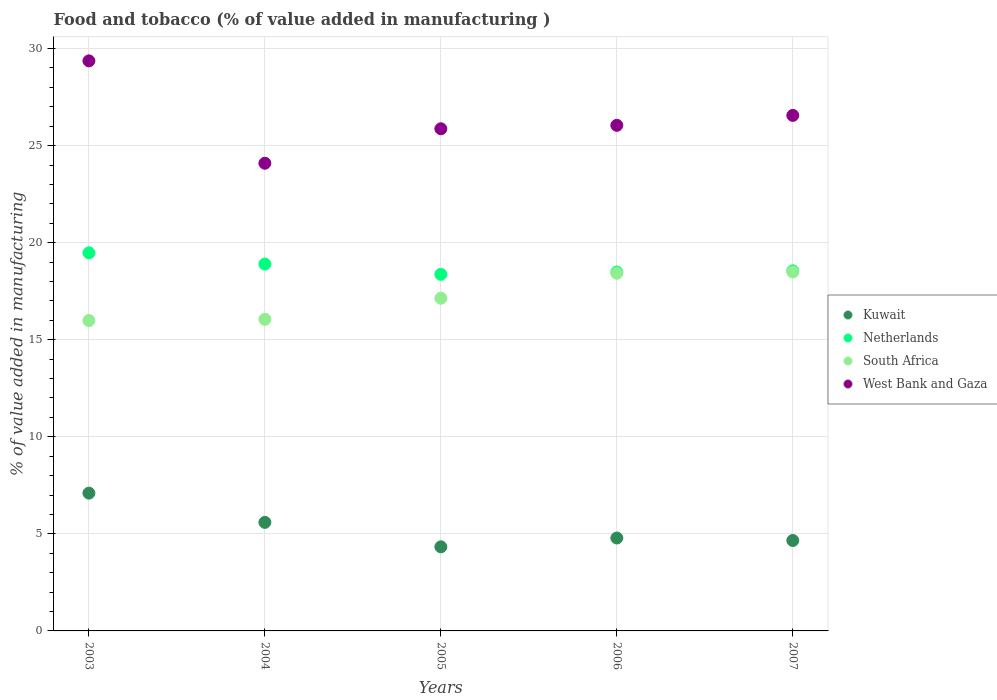How many different coloured dotlines are there?
Offer a very short reply. 4. What is the value added in manufacturing food and tobacco in Netherlands in 2006?
Ensure brevity in your answer.  18.49. Across all years, what is the maximum value added in manufacturing food and tobacco in Kuwait?
Offer a terse response. 7.1. Across all years, what is the minimum value added in manufacturing food and tobacco in Netherlands?
Provide a succinct answer. 18.37. In which year was the value added in manufacturing food and tobacco in West Bank and Gaza minimum?
Your answer should be very brief. 2004. What is the total value added in manufacturing food and tobacco in Kuwait in the graph?
Provide a succinct answer. 26.47. What is the difference between the value added in manufacturing food and tobacco in Netherlands in 2004 and that in 2005?
Provide a short and direct response. 0.53. What is the difference between the value added in manufacturing food and tobacco in West Bank and Gaza in 2004 and the value added in manufacturing food and tobacco in South Africa in 2007?
Offer a terse response. 5.6. What is the average value added in manufacturing food and tobacco in South Africa per year?
Ensure brevity in your answer.  17.22. In the year 2004, what is the difference between the value added in manufacturing food and tobacco in Netherlands and value added in manufacturing food and tobacco in West Bank and Gaza?
Offer a very short reply. -5.19. What is the ratio of the value added in manufacturing food and tobacco in South Africa in 2003 to that in 2005?
Provide a short and direct response. 0.93. Is the value added in manufacturing food and tobacco in South Africa in 2005 less than that in 2006?
Your answer should be compact. Yes. What is the difference between the highest and the second highest value added in manufacturing food and tobacco in Netherlands?
Ensure brevity in your answer.  0.58. What is the difference between the highest and the lowest value added in manufacturing food and tobacco in Netherlands?
Give a very brief answer. 1.11. In how many years, is the value added in manufacturing food and tobacco in Kuwait greater than the average value added in manufacturing food and tobacco in Kuwait taken over all years?
Provide a succinct answer. 2. Is the sum of the value added in manufacturing food and tobacco in Netherlands in 2005 and 2007 greater than the maximum value added in manufacturing food and tobacco in Kuwait across all years?
Your answer should be very brief. Yes. Is it the case that in every year, the sum of the value added in manufacturing food and tobacco in West Bank and Gaza and value added in manufacturing food and tobacco in Netherlands  is greater than the sum of value added in manufacturing food and tobacco in South Africa and value added in manufacturing food and tobacco in Kuwait?
Ensure brevity in your answer.  No. Is it the case that in every year, the sum of the value added in manufacturing food and tobacco in South Africa and value added in manufacturing food and tobacco in Netherlands  is greater than the value added in manufacturing food and tobacco in West Bank and Gaza?
Your response must be concise. Yes. Does the value added in manufacturing food and tobacco in West Bank and Gaza monotonically increase over the years?
Ensure brevity in your answer.  No. How many years are there in the graph?
Offer a very short reply. 5. What is the difference between two consecutive major ticks on the Y-axis?
Keep it short and to the point. 5. Are the values on the major ticks of Y-axis written in scientific E-notation?
Offer a very short reply. No. Does the graph contain any zero values?
Offer a terse response. No. Does the graph contain grids?
Offer a terse response. Yes. How are the legend labels stacked?
Offer a terse response. Vertical. What is the title of the graph?
Keep it short and to the point. Food and tobacco (% of value added in manufacturing ). What is the label or title of the Y-axis?
Your answer should be compact. % of value added in manufacturing. What is the % of value added in manufacturing in Kuwait in 2003?
Provide a succinct answer. 7.1. What is the % of value added in manufacturing in Netherlands in 2003?
Provide a succinct answer. 19.48. What is the % of value added in manufacturing of South Africa in 2003?
Your answer should be very brief. 15.99. What is the % of value added in manufacturing in West Bank and Gaza in 2003?
Keep it short and to the point. 29.36. What is the % of value added in manufacturing of Kuwait in 2004?
Provide a short and direct response. 5.59. What is the % of value added in manufacturing of Netherlands in 2004?
Give a very brief answer. 18.9. What is the % of value added in manufacturing in South Africa in 2004?
Your answer should be very brief. 16.05. What is the % of value added in manufacturing of West Bank and Gaza in 2004?
Ensure brevity in your answer.  24.09. What is the % of value added in manufacturing in Kuwait in 2005?
Offer a terse response. 4.33. What is the % of value added in manufacturing in Netherlands in 2005?
Your answer should be very brief. 18.37. What is the % of value added in manufacturing of South Africa in 2005?
Your response must be concise. 17.14. What is the % of value added in manufacturing in West Bank and Gaza in 2005?
Provide a succinct answer. 25.87. What is the % of value added in manufacturing in Kuwait in 2006?
Keep it short and to the point. 4.79. What is the % of value added in manufacturing in Netherlands in 2006?
Offer a very short reply. 18.49. What is the % of value added in manufacturing in South Africa in 2006?
Keep it short and to the point. 18.42. What is the % of value added in manufacturing in West Bank and Gaza in 2006?
Give a very brief answer. 26.04. What is the % of value added in manufacturing of Kuwait in 2007?
Provide a succinct answer. 4.66. What is the % of value added in manufacturing in Netherlands in 2007?
Offer a terse response. 18.55. What is the % of value added in manufacturing of South Africa in 2007?
Your answer should be compact. 18.49. What is the % of value added in manufacturing of West Bank and Gaza in 2007?
Offer a very short reply. 26.56. Across all years, what is the maximum % of value added in manufacturing in Kuwait?
Offer a terse response. 7.1. Across all years, what is the maximum % of value added in manufacturing of Netherlands?
Provide a short and direct response. 19.48. Across all years, what is the maximum % of value added in manufacturing in South Africa?
Provide a succinct answer. 18.49. Across all years, what is the maximum % of value added in manufacturing of West Bank and Gaza?
Offer a very short reply. 29.36. Across all years, what is the minimum % of value added in manufacturing in Kuwait?
Make the answer very short. 4.33. Across all years, what is the minimum % of value added in manufacturing of Netherlands?
Your response must be concise. 18.37. Across all years, what is the minimum % of value added in manufacturing in South Africa?
Ensure brevity in your answer.  15.99. Across all years, what is the minimum % of value added in manufacturing in West Bank and Gaza?
Your response must be concise. 24.09. What is the total % of value added in manufacturing of Kuwait in the graph?
Offer a terse response. 26.47. What is the total % of value added in manufacturing in Netherlands in the graph?
Ensure brevity in your answer.  93.78. What is the total % of value added in manufacturing in South Africa in the graph?
Your answer should be compact. 86.09. What is the total % of value added in manufacturing in West Bank and Gaza in the graph?
Provide a short and direct response. 131.92. What is the difference between the % of value added in manufacturing in Kuwait in 2003 and that in 2004?
Make the answer very short. 1.51. What is the difference between the % of value added in manufacturing of Netherlands in 2003 and that in 2004?
Provide a succinct answer. 0.58. What is the difference between the % of value added in manufacturing in South Africa in 2003 and that in 2004?
Provide a short and direct response. -0.06. What is the difference between the % of value added in manufacturing in West Bank and Gaza in 2003 and that in 2004?
Provide a succinct answer. 5.27. What is the difference between the % of value added in manufacturing in Kuwait in 2003 and that in 2005?
Your response must be concise. 2.77. What is the difference between the % of value added in manufacturing of Netherlands in 2003 and that in 2005?
Make the answer very short. 1.11. What is the difference between the % of value added in manufacturing in South Africa in 2003 and that in 2005?
Give a very brief answer. -1.15. What is the difference between the % of value added in manufacturing of West Bank and Gaza in 2003 and that in 2005?
Offer a very short reply. 3.5. What is the difference between the % of value added in manufacturing in Kuwait in 2003 and that in 2006?
Your answer should be very brief. 2.31. What is the difference between the % of value added in manufacturing in South Africa in 2003 and that in 2006?
Your answer should be very brief. -2.43. What is the difference between the % of value added in manufacturing of West Bank and Gaza in 2003 and that in 2006?
Provide a succinct answer. 3.32. What is the difference between the % of value added in manufacturing of Kuwait in 2003 and that in 2007?
Keep it short and to the point. 2.44. What is the difference between the % of value added in manufacturing in Netherlands in 2003 and that in 2007?
Provide a succinct answer. 0.93. What is the difference between the % of value added in manufacturing in South Africa in 2003 and that in 2007?
Offer a very short reply. -2.5. What is the difference between the % of value added in manufacturing of West Bank and Gaza in 2003 and that in 2007?
Provide a short and direct response. 2.81. What is the difference between the % of value added in manufacturing in Kuwait in 2004 and that in 2005?
Offer a terse response. 1.26. What is the difference between the % of value added in manufacturing of Netherlands in 2004 and that in 2005?
Offer a terse response. 0.53. What is the difference between the % of value added in manufacturing of South Africa in 2004 and that in 2005?
Ensure brevity in your answer.  -1.09. What is the difference between the % of value added in manufacturing of West Bank and Gaza in 2004 and that in 2005?
Your response must be concise. -1.78. What is the difference between the % of value added in manufacturing of Kuwait in 2004 and that in 2006?
Your answer should be very brief. 0.81. What is the difference between the % of value added in manufacturing of Netherlands in 2004 and that in 2006?
Your answer should be compact. 0.41. What is the difference between the % of value added in manufacturing in South Africa in 2004 and that in 2006?
Your answer should be compact. -2.37. What is the difference between the % of value added in manufacturing of West Bank and Gaza in 2004 and that in 2006?
Provide a succinct answer. -1.95. What is the difference between the % of value added in manufacturing of Kuwait in 2004 and that in 2007?
Offer a terse response. 0.93. What is the difference between the % of value added in manufacturing in Netherlands in 2004 and that in 2007?
Offer a terse response. 0.35. What is the difference between the % of value added in manufacturing of South Africa in 2004 and that in 2007?
Your response must be concise. -2.44. What is the difference between the % of value added in manufacturing of West Bank and Gaza in 2004 and that in 2007?
Ensure brevity in your answer.  -2.46. What is the difference between the % of value added in manufacturing in Kuwait in 2005 and that in 2006?
Provide a short and direct response. -0.45. What is the difference between the % of value added in manufacturing in Netherlands in 2005 and that in 2006?
Keep it short and to the point. -0.12. What is the difference between the % of value added in manufacturing in South Africa in 2005 and that in 2006?
Ensure brevity in your answer.  -1.29. What is the difference between the % of value added in manufacturing of West Bank and Gaza in 2005 and that in 2006?
Make the answer very short. -0.18. What is the difference between the % of value added in manufacturing in Kuwait in 2005 and that in 2007?
Offer a terse response. -0.33. What is the difference between the % of value added in manufacturing of Netherlands in 2005 and that in 2007?
Offer a very short reply. -0.18. What is the difference between the % of value added in manufacturing in South Africa in 2005 and that in 2007?
Your response must be concise. -1.35. What is the difference between the % of value added in manufacturing of West Bank and Gaza in 2005 and that in 2007?
Ensure brevity in your answer.  -0.69. What is the difference between the % of value added in manufacturing of Kuwait in 2006 and that in 2007?
Keep it short and to the point. 0.13. What is the difference between the % of value added in manufacturing of Netherlands in 2006 and that in 2007?
Offer a terse response. -0.06. What is the difference between the % of value added in manufacturing in South Africa in 2006 and that in 2007?
Offer a very short reply. -0.07. What is the difference between the % of value added in manufacturing of West Bank and Gaza in 2006 and that in 2007?
Offer a terse response. -0.51. What is the difference between the % of value added in manufacturing of Kuwait in 2003 and the % of value added in manufacturing of Netherlands in 2004?
Make the answer very short. -11.8. What is the difference between the % of value added in manufacturing of Kuwait in 2003 and the % of value added in manufacturing of South Africa in 2004?
Give a very brief answer. -8.95. What is the difference between the % of value added in manufacturing of Kuwait in 2003 and the % of value added in manufacturing of West Bank and Gaza in 2004?
Your response must be concise. -16.99. What is the difference between the % of value added in manufacturing in Netherlands in 2003 and the % of value added in manufacturing in South Africa in 2004?
Offer a terse response. 3.43. What is the difference between the % of value added in manufacturing in Netherlands in 2003 and the % of value added in manufacturing in West Bank and Gaza in 2004?
Your answer should be compact. -4.62. What is the difference between the % of value added in manufacturing of South Africa in 2003 and the % of value added in manufacturing of West Bank and Gaza in 2004?
Provide a succinct answer. -8.1. What is the difference between the % of value added in manufacturing in Kuwait in 2003 and the % of value added in manufacturing in Netherlands in 2005?
Make the answer very short. -11.27. What is the difference between the % of value added in manufacturing of Kuwait in 2003 and the % of value added in manufacturing of South Africa in 2005?
Your response must be concise. -10.04. What is the difference between the % of value added in manufacturing in Kuwait in 2003 and the % of value added in manufacturing in West Bank and Gaza in 2005?
Your answer should be compact. -18.77. What is the difference between the % of value added in manufacturing in Netherlands in 2003 and the % of value added in manufacturing in South Africa in 2005?
Provide a succinct answer. 2.34. What is the difference between the % of value added in manufacturing of Netherlands in 2003 and the % of value added in manufacturing of West Bank and Gaza in 2005?
Ensure brevity in your answer.  -6.39. What is the difference between the % of value added in manufacturing in South Africa in 2003 and the % of value added in manufacturing in West Bank and Gaza in 2005?
Your answer should be compact. -9.88. What is the difference between the % of value added in manufacturing of Kuwait in 2003 and the % of value added in manufacturing of Netherlands in 2006?
Offer a terse response. -11.39. What is the difference between the % of value added in manufacturing in Kuwait in 2003 and the % of value added in manufacturing in South Africa in 2006?
Provide a succinct answer. -11.33. What is the difference between the % of value added in manufacturing in Kuwait in 2003 and the % of value added in manufacturing in West Bank and Gaza in 2006?
Keep it short and to the point. -18.95. What is the difference between the % of value added in manufacturing of Netherlands in 2003 and the % of value added in manufacturing of South Africa in 2006?
Give a very brief answer. 1.05. What is the difference between the % of value added in manufacturing of Netherlands in 2003 and the % of value added in manufacturing of West Bank and Gaza in 2006?
Your response must be concise. -6.57. What is the difference between the % of value added in manufacturing of South Africa in 2003 and the % of value added in manufacturing of West Bank and Gaza in 2006?
Your answer should be compact. -10.05. What is the difference between the % of value added in manufacturing of Kuwait in 2003 and the % of value added in manufacturing of Netherlands in 2007?
Keep it short and to the point. -11.45. What is the difference between the % of value added in manufacturing of Kuwait in 2003 and the % of value added in manufacturing of South Africa in 2007?
Make the answer very short. -11.39. What is the difference between the % of value added in manufacturing in Kuwait in 2003 and the % of value added in manufacturing in West Bank and Gaza in 2007?
Give a very brief answer. -19.46. What is the difference between the % of value added in manufacturing in Netherlands in 2003 and the % of value added in manufacturing in South Africa in 2007?
Provide a short and direct response. 0.98. What is the difference between the % of value added in manufacturing in Netherlands in 2003 and the % of value added in manufacturing in West Bank and Gaza in 2007?
Offer a very short reply. -7.08. What is the difference between the % of value added in manufacturing of South Africa in 2003 and the % of value added in manufacturing of West Bank and Gaza in 2007?
Your answer should be very brief. -10.57. What is the difference between the % of value added in manufacturing of Kuwait in 2004 and the % of value added in manufacturing of Netherlands in 2005?
Your response must be concise. -12.78. What is the difference between the % of value added in manufacturing of Kuwait in 2004 and the % of value added in manufacturing of South Africa in 2005?
Make the answer very short. -11.55. What is the difference between the % of value added in manufacturing in Kuwait in 2004 and the % of value added in manufacturing in West Bank and Gaza in 2005?
Provide a short and direct response. -20.28. What is the difference between the % of value added in manufacturing of Netherlands in 2004 and the % of value added in manufacturing of South Africa in 2005?
Offer a terse response. 1.76. What is the difference between the % of value added in manufacturing in Netherlands in 2004 and the % of value added in manufacturing in West Bank and Gaza in 2005?
Ensure brevity in your answer.  -6.97. What is the difference between the % of value added in manufacturing of South Africa in 2004 and the % of value added in manufacturing of West Bank and Gaza in 2005?
Provide a succinct answer. -9.82. What is the difference between the % of value added in manufacturing in Kuwait in 2004 and the % of value added in manufacturing in Netherlands in 2006?
Ensure brevity in your answer.  -12.9. What is the difference between the % of value added in manufacturing of Kuwait in 2004 and the % of value added in manufacturing of South Africa in 2006?
Provide a succinct answer. -12.83. What is the difference between the % of value added in manufacturing in Kuwait in 2004 and the % of value added in manufacturing in West Bank and Gaza in 2006?
Provide a succinct answer. -20.45. What is the difference between the % of value added in manufacturing in Netherlands in 2004 and the % of value added in manufacturing in South Africa in 2006?
Ensure brevity in your answer.  0.47. What is the difference between the % of value added in manufacturing in Netherlands in 2004 and the % of value added in manufacturing in West Bank and Gaza in 2006?
Your answer should be compact. -7.15. What is the difference between the % of value added in manufacturing in South Africa in 2004 and the % of value added in manufacturing in West Bank and Gaza in 2006?
Provide a succinct answer. -9.99. What is the difference between the % of value added in manufacturing of Kuwait in 2004 and the % of value added in manufacturing of Netherlands in 2007?
Your answer should be compact. -12.96. What is the difference between the % of value added in manufacturing of Kuwait in 2004 and the % of value added in manufacturing of South Africa in 2007?
Provide a succinct answer. -12.9. What is the difference between the % of value added in manufacturing of Kuwait in 2004 and the % of value added in manufacturing of West Bank and Gaza in 2007?
Keep it short and to the point. -20.96. What is the difference between the % of value added in manufacturing of Netherlands in 2004 and the % of value added in manufacturing of South Africa in 2007?
Give a very brief answer. 0.41. What is the difference between the % of value added in manufacturing of Netherlands in 2004 and the % of value added in manufacturing of West Bank and Gaza in 2007?
Offer a very short reply. -7.66. What is the difference between the % of value added in manufacturing of South Africa in 2004 and the % of value added in manufacturing of West Bank and Gaza in 2007?
Provide a succinct answer. -10.5. What is the difference between the % of value added in manufacturing of Kuwait in 2005 and the % of value added in manufacturing of Netherlands in 2006?
Your response must be concise. -14.16. What is the difference between the % of value added in manufacturing in Kuwait in 2005 and the % of value added in manufacturing in South Africa in 2006?
Your answer should be compact. -14.09. What is the difference between the % of value added in manufacturing of Kuwait in 2005 and the % of value added in manufacturing of West Bank and Gaza in 2006?
Your response must be concise. -21.71. What is the difference between the % of value added in manufacturing of Netherlands in 2005 and the % of value added in manufacturing of South Africa in 2006?
Make the answer very short. -0.06. What is the difference between the % of value added in manufacturing of Netherlands in 2005 and the % of value added in manufacturing of West Bank and Gaza in 2006?
Your answer should be compact. -7.68. What is the difference between the % of value added in manufacturing in South Africa in 2005 and the % of value added in manufacturing in West Bank and Gaza in 2006?
Your answer should be very brief. -8.91. What is the difference between the % of value added in manufacturing of Kuwait in 2005 and the % of value added in manufacturing of Netherlands in 2007?
Offer a very short reply. -14.22. What is the difference between the % of value added in manufacturing in Kuwait in 2005 and the % of value added in manufacturing in South Africa in 2007?
Provide a succinct answer. -14.16. What is the difference between the % of value added in manufacturing in Kuwait in 2005 and the % of value added in manufacturing in West Bank and Gaza in 2007?
Make the answer very short. -22.22. What is the difference between the % of value added in manufacturing of Netherlands in 2005 and the % of value added in manufacturing of South Africa in 2007?
Give a very brief answer. -0.12. What is the difference between the % of value added in manufacturing of Netherlands in 2005 and the % of value added in manufacturing of West Bank and Gaza in 2007?
Keep it short and to the point. -8.19. What is the difference between the % of value added in manufacturing of South Africa in 2005 and the % of value added in manufacturing of West Bank and Gaza in 2007?
Your answer should be compact. -9.42. What is the difference between the % of value added in manufacturing in Kuwait in 2006 and the % of value added in manufacturing in Netherlands in 2007?
Your answer should be very brief. -13.76. What is the difference between the % of value added in manufacturing of Kuwait in 2006 and the % of value added in manufacturing of South Africa in 2007?
Keep it short and to the point. -13.71. What is the difference between the % of value added in manufacturing of Kuwait in 2006 and the % of value added in manufacturing of West Bank and Gaza in 2007?
Your answer should be compact. -21.77. What is the difference between the % of value added in manufacturing of Netherlands in 2006 and the % of value added in manufacturing of South Africa in 2007?
Your response must be concise. -0. What is the difference between the % of value added in manufacturing of Netherlands in 2006 and the % of value added in manufacturing of West Bank and Gaza in 2007?
Make the answer very short. -8.07. What is the difference between the % of value added in manufacturing of South Africa in 2006 and the % of value added in manufacturing of West Bank and Gaza in 2007?
Your answer should be very brief. -8.13. What is the average % of value added in manufacturing of Kuwait per year?
Keep it short and to the point. 5.29. What is the average % of value added in manufacturing of Netherlands per year?
Your answer should be compact. 18.76. What is the average % of value added in manufacturing in South Africa per year?
Provide a succinct answer. 17.22. What is the average % of value added in manufacturing in West Bank and Gaza per year?
Make the answer very short. 26.38. In the year 2003, what is the difference between the % of value added in manufacturing in Kuwait and % of value added in manufacturing in Netherlands?
Ensure brevity in your answer.  -12.38. In the year 2003, what is the difference between the % of value added in manufacturing in Kuwait and % of value added in manufacturing in South Africa?
Provide a short and direct response. -8.89. In the year 2003, what is the difference between the % of value added in manufacturing in Kuwait and % of value added in manufacturing in West Bank and Gaza?
Offer a terse response. -22.27. In the year 2003, what is the difference between the % of value added in manufacturing in Netherlands and % of value added in manufacturing in South Africa?
Offer a very short reply. 3.49. In the year 2003, what is the difference between the % of value added in manufacturing in Netherlands and % of value added in manufacturing in West Bank and Gaza?
Ensure brevity in your answer.  -9.89. In the year 2003, what is the difference between the % of value added in manufacturing of South Africa and % of value added in manufacturing of West Bank and Gaza?
Your answer should be compact. -13.37. In the year 2004, what is the difference between the % of value added in manufacturing in Kuwait and % of value added in manufacturing in Netherlands?
Provide a succinct answer. -13.31. In the year 2004, what is the difference between the % of value added in manufacturing of Kuwait and % of value added in manufacturing of South Africa?
Keep it short and to the point. -10.46. In the year 2004, what is the difference between the % of value added in manufacturing in Kuwait and % of value added in manufacturing in West Bank and Gaza?
Keep it short and to the point. -18.5. In the year 2004, what is the difference between the % of value added in manufacturing of Netherlands and % of value added in manufacturing of South Africa?
Give a very brief answer. 2.85. In the year 2004, what is the difference between the % of value added in manufacturing in Netherlands and % of value added in manufacturing in West Bank and Gaza?
Your response must be concise. -5.19. In the year 2004, what is the difference between the % of value added in manufacturing of South Africa and % of value added in manufacturing of West Bank and Gaza?
Offer a very short reply. -8.04. In the year 2005, what is the difference between the % of value added in manufacturing of Kuwait and % of value added in manufacturing of Netherlands?
Your response must be concise. -14.04. In the year 2005, what is the difference between the % of value added in manufacturing in Kuwait and % of value added in manufacturing in South Africa?
Make the answer very short. -12.81. In the year 2005, what is the difference between the % of value added in manufacturing in Kuwait and % of value added in manufacturing in West Bank and Gaza?
Keep it short and to the point. -21.54. In the year 2005, what is the difference between the % of value added in manufacturing of Netherlands and % of value added in manufacturing of South Africa?
Offer a very short reply. 1.23. In the year 2005, what is the difference between the % of value added in manufacturing of Netherlands and % of value added in manufacturing of West Bank and Gaza?
Provide a short and direct response. -7.5. In the year 2005, what is the difference between the % of value added in manufacturing of South Africa and % of value added in manufacturing of West Bank and Gaza?
Give a very brief answer. -8.73. In the year 2006, what is the difference between the % of value added in manufacturing in Kuwait and % of value added in manufacturing in Netherlands?
Make the answer very short. -13.7. In the year 2006, what is the difference between the % of value added in manufacturing of Kuwait and % of value added in manufacturing of South Africa?
Offer a very short reply. -13.64. In the year 2006, what is the difference between the % of value added in manufacturing of Kuwait and % of value added in manufacturing of West Bank and Gaza?
Provide a succinct answer. -21.26. In the year 2006, what is the difference between the % of value added in manufacturing of Netherlands and % of value added in manufacturing of South Africa?
Keep it short and to the point. 0.06. In the year 2006, what is the difference between the % of value added in manufacturing of Netherlands and % of value added in manufacturing of West Bank and Gaza?
Offer a very short reply. -7.56. In the year 2006, what is the difference between the % of value added in manufacturing of South Africa and % of value added in manufacturing of West Bank and Gaza?
Your answer should be very brief. -7.62. In the year 2007, what is the difference between the % of value added in manufacturing of Kuwait and % of value added in manufacturing of Netherlands?
Provide a succinct answer. -13.89. In the year 2007, what is the difference between the % of value added in manufacturing in Kuwait and % of value added in manufacturing in South Africa?
Your answer should be compact. -13.83. In the year 2007, what is the difference between the % of value added in manufacturing in Kuwait and % of value added in manufacturing in West Bank and Gaza?
Keep it short and to the point. -21.9. In the year 2007, what is the difference between the % of value added in manufacturing of Netherlands and % of value added in manufacturing of South Africa?
Your response must be concise. 0.06. In the year 2007, what is the difference between the % of value added in manufacturing of Netherlands and % of value added in manufacturing of West Bank and Gaza?
Make the answer very short. -8. In the year 2007, what is the difference between the % of value added in manufacturing of South Africa and % of value added in manufacturing of West Bank and Gaza?
Make the answer very short. -8.06. What is the ratio of the % of value added in manufacturing of Kuwait in 2003 to that in 2004?
Provide a succinct answer. 1.27. What is the ratio of the % of value added in manufacturing of Netherlands in 2003 to that in 2004?
Provide a short and direct response. 1.03. What is the ratio of the % of value added in manufacturing in South Africa in 2003 to that in 2004?
Give a very brief answer. 1. What is the ratio of the % of value added in manufacturing in West Bank and Gaza in 2003 to that in 2004?
Your answer should be compact. 1.22. What is the ratio of the % of value added in manufacturing in Kuwait in 2003 to that in 2005?
Ensure brevity in your answer.  1.64. What is the ratio of the % of value added in manufacturing in Netherlands in 2003 to that in 2005?
Provide a succinct answer. 1.06. What is the ratio of the % of value added in manufacturing of South Africa in 2003 to that in 2005?
Keep it short and to the point. 0.93. What is the ratio of the % of value added in manufacturing of West Bank and Gaza in 2003 to that in 2005?
Your answer should be very brief. 1.14. What is the ratio of the % of value added in manufacturing in Kuwait in 2003 to that in 2006?
Your answer should be compact. 1.48. What is the ratio of the % of value added in manufacturing of Netherlands in 2003 to that in 2006?
Provide a short and direct response. 1.05. What is the ratio of the % of value added in manufacturing of South Africa in 2003 to that in 2006?
Provide a short and direct response. 0.87. What is the ratio of the % of value added in manufacturing in West Bank and Gaza in 2003 to that in 2006?
Your answer should be very brief. 1.13. What is the ratio of the % of value added in manufacturing in Kuwait in 2003 to that in 2007?
Make the answer very short. 1.52. What is the ratio of the % of value added in manufacturing in Netherlands in 2003 to that in 2007?
Offer a terse response. 1.05. What is the ratio of the % of value added in manufacturing in South Africa in 2003 to that in 2007?
Offer a very short reply. 0.86. What is the ratio of the % of value added in manufacturing of West Bank and Gaza in 2003 to that in 2007?
Offer a terse response. 1.11. What is the ratio of the % of value added in manufacturing in Kuwait in 2004 to that in 2005?
Your answer should be compact. 1.29. What is the ratio of the % of value added in manufacturing in Netherlands in 2004 to that in 2005?
Your answer should be very brief. 1.03. What is the ratio of the % of value added in manufacturing of South Africa in 2004 to that in 2005?
Make the answer very short. 0.94. What is the ratio of the % of value added in manufacturing of West Bank and Gaza in 2004 to that in 2005?
Provide a succinct answer. 0.93. What is the ratio of the % of value added in manufacturing in Kuwait in 2004 to that in 2006?
Your response must be concise. 1.17. What is the ratio of the % of value added in manufacturing of Netherlands in 2004 to that in 2006?
Your response must be concise. 1.02. What is the ratio of the % of value added in manufacturing of South Africa in 2004 to that in 2006?
Provide a succinct answer. 0.87. What is the ratio of the % of value added in manufacturing of West Bank and Gaza in 2004 to that in 2006?
Your answer should be very brief. 0.93. What is the ratio of the % of value added in manufacturing of Kuwait in 2004 to that in 2007?
Your answer should be very brief. 1.2. What is the ratio of the % of value added in manufacturing of Netherlands in 2004 to that in 2007?
Give a very brief answer. 1.02. What is the ratio of the % of value added in manufacturing of South Africa in 2004 to that in 2007?
Your answer should be very brief. 0.87. What is the ratio of the % of value added in manufacturing of West Bank and Gaza in 2004 to that in 2007?
Ensure brevity in your answer.  0.91. What is the ratio of the % of value added in manufacturing of Kuwait in 2005 to that in 2006?
Make the answer very short. 0.91. What is the ratio of the % of value added in manufacturing in South Africa in 2005 to that in 2006?
Offer a terse response. 0.93. What is the ratio of the % of value added in manufacturing of Kuwait in 2005 to that in 2007?
Your response must be concise. 0.93. What is the ratio of the % of value added in manufacturing of Netherlands in 2005 to that in 2007?
Offer a terse response. 0.99. What is the ratio of the % of value added in manufacturing of South Africa in 2005 to that in 2007?
Give a very brief answer. 0.93. What is the ratio of the % of value added in manufacturing of West Bank and Gaza in 2005 to that in 2007?
Keep it short and to the point. 0.97. What is the ratio of the % of value added in manufacturing in Kuwait in 2006 to that in 2007?
Offer a terse response. 1.03. What is the ratio of the % of value added in manufacturing of Netherlands in 2006 to that in 2007?
Your answer should be very brief. 1. What is the ratio of the % of value added in manufacturing in South Africa in 2006 to that in 2007?
Offer a terse response. 1. What is the ratio of the % of value added in manufacturing of West Bank and Gaza in 2006 to that in 2007?
Your answer should be compact. 0.98. What is the difference between the highest and the second highest % of value added in manufacturing of Kuwait?
Offer a terse response. 1.51. What is the difference between the highest and the second highest % of value added in manufacturing of Netherlands?
Offer a very short reply. 0.58. What is the difference between the highest and the second highest % of value added in manufacturing in South Africa?
Keep it short and to the point. 0.07. What is the difference between the highest and the second highest % of value added in manufacturing in West Bank and Gaza?
Keep it short and to the point. 2.81. What is the difference between the highest and the lowest % of value added in manufacturing in Kuwait?
Make the answer very short. 2.77. What is the difference between the highest and the lowest % of value added in manufacturing in Netherlands?
Make the answer very short. 1.11. What is the difference between the highest and the lowest % of value added in manufacturing of South Africa?
Ensure brevity in your answer.  2.5. What is the difference between the highest and the lowest % of value added in manufacturing in West Bank and Gaza?
Offer a very short reply. 5.27. 